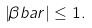Convert formula to latex. <formula><loc_0><loc_0><loc_500><loc_500>\left | \beta b a r \right | \leq 1 .</formula> 